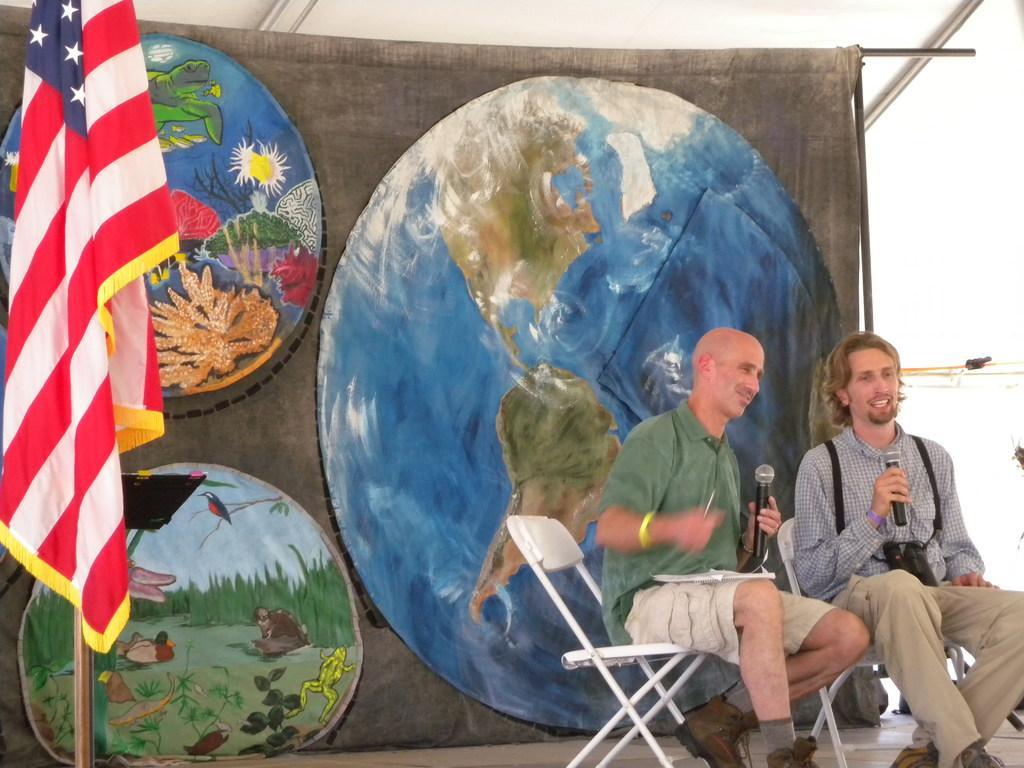Describe this image in one or two sentences. There are two men sitting on chairs and holding microphones, behind these two men we can see banner. We can see stand and flag. 